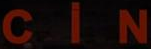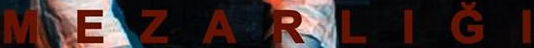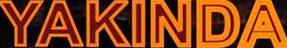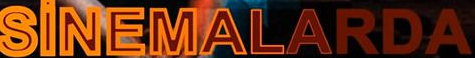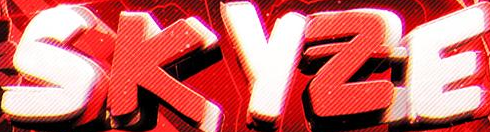What text is displayed in these images sequentially, separated by a semicolon? CiN; MEZARLIĞI; YAKINDA; SiNEMALARDA; SKYZE 